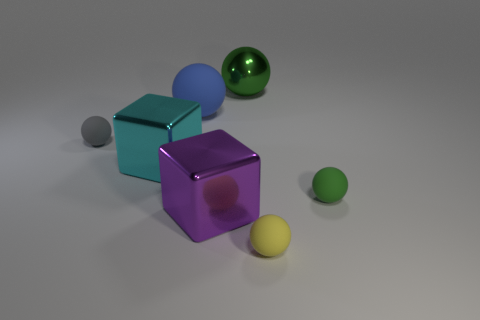Subtract all yellow spheres. How many spheres are left? 4 Subtract all metal spheres. How many spheres are left? 4 Subtract all brown spheres. Subtract all cyan cubes. How many spheres are left? 5 Add 3 large cyan metallic blocks. How many objects exist? 10 Subtract all spheres. How many objects are left? 2 Add 5 large blue matte spheres. How many large blue matte spheres are left? 6 Add 3 small gray objects. How many small gray objects exist? 4 Subtract 0 red cylinders. How many objects are left? 7 Subtract all tiny green spheres. Subtract all gray balls. How many objects are left? 5 